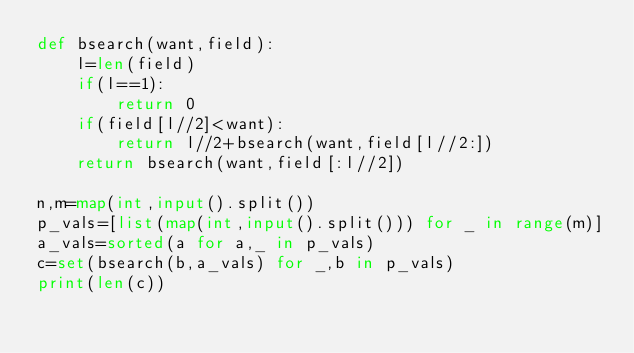Convert code to text. <code><loc_0><loc_0><loc_500><loc_500><_Python_>def bsearch(want,field):
    l=len(field)
    if(l==1):
        return 0
    if(field[l//2]<want):
        return l//2+bsearch(want,field[l//2:])
    return bsearch(want,field[:l//2])

n,m=map(int,input().split())
p_vals=[list(map(int,input().split())) for _ in range(m)]
a_vals=sorted(a for a,_ in p_vals)
c=set(bsearch(b,a_vals) for _,b in p_vals)
print(len(c))</code> 